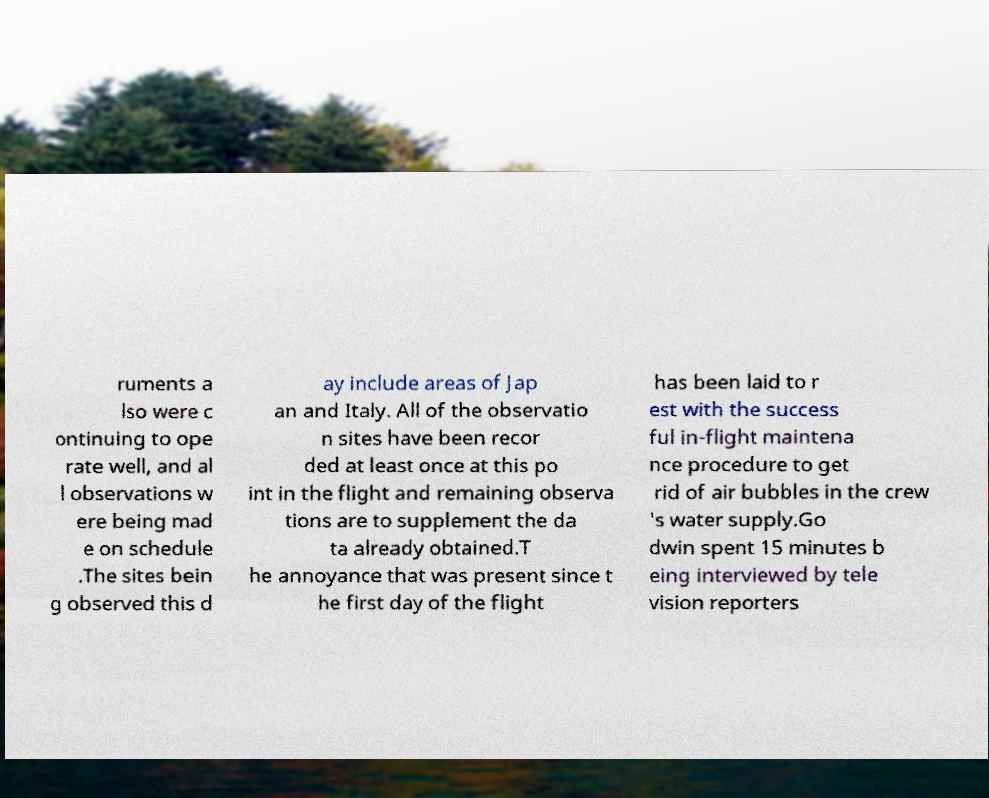Please identify and transcribe the text found in this image. ruments a lso were c ontinuing to ope rate well, and al l observations w ere being mad e on schedule .The sites bein g observed this d ay include areas of Jap an and Italy. All of the observatio n sites have been recor ded at least once at this po int in the flight and remaining observa tions are to supplement the da ta already obtained.T he annoyance that was present since t he first day of the flight has been laid to r est with the success ful in-flight maintena nce procedure to get rid of air bubbles in the crew 's water supply.Go dwin spent 15 minutes b eing interviewed by tele vision reporters 